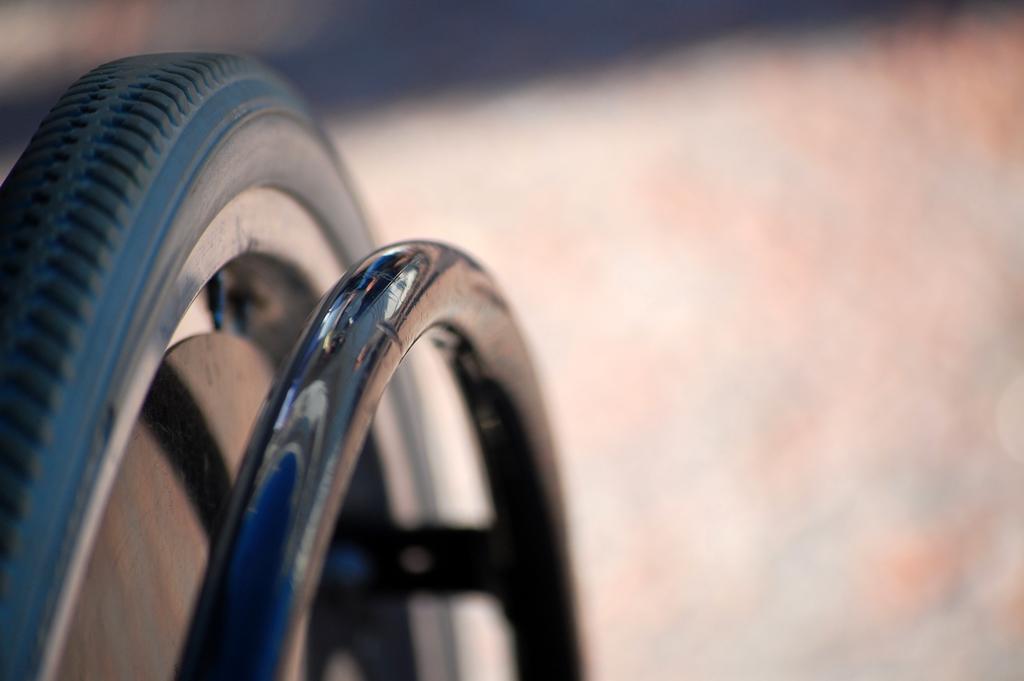In one or two sentences, can you explain what this image depicts? This image is taken outdoors. In this image the background a little blurred. On the left side of the image there is a wheel and a tire. 